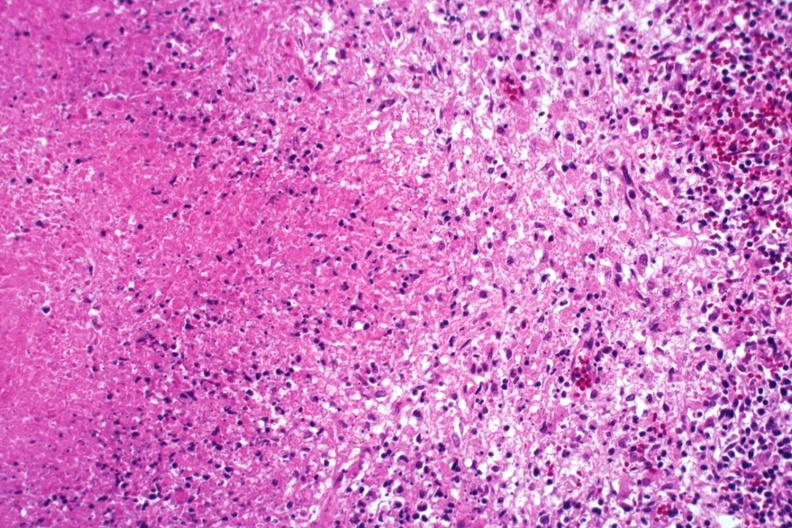what is present?
Answer the question using a single word or phrase. Tuberculosis 